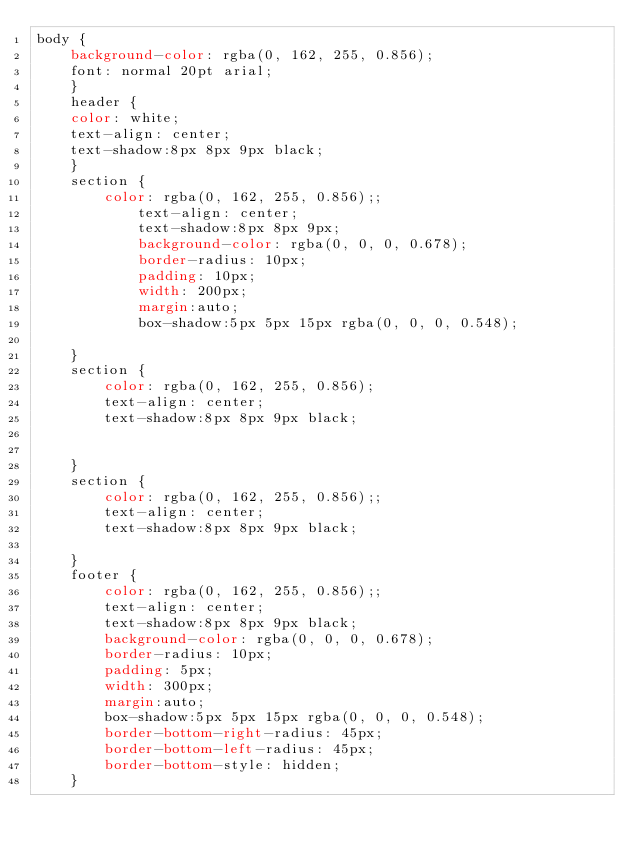Convert code to text. <code><loc_0><loc_0><loc_500><loc_500><_CSS_>body {
    background-color: rgba(0, 162, 255, 0.856);
    font: normal 20pt arial;
    }
    header {
    color: white;
    text-align: center;
    text-shadow:8px 8px 9px black;
    }
    section {
        color: rgba(0, 162, 255, 0.856);;
            text-align: center;   
            text-shadow:8px 8px 9px;
            background-color: rgba(0, 0, 0, 0.678);
            border-radius: 10px;
            padding: 10px;
            width: 200px;
            margin:auto;
            box-shadow:5px 5px 15px rgba(0, 0, 0, 0.548);
            
    }
    section {
        color: rgba(0, 162, 255, 0.856);
        text-align: center;
        text-shadow:8px 8px 9px black;
       
    
    }
    section {
        color: rgba(0, 162, 255, 0.856);;
        text-align: center;
        text-shadow:8px 8px 9px black;

    }
    footer {
        color: rgba(0, 162, 255, 0.856);;
        text-align: center;
        text-shadow:8px 8px 9px black;
        background-color: rgba(0, 0, 0, 0.678);
        border-radius: 10px;
        padding: 5px;
        width: 300px;
        margin:auto;
        box-shadow:5px 5px 15px rgba(0, 0, 0, 0.548);  
        border-bottom-right-radius: 45px;
        border-bottom-left-radius: 45px;
        border-bottom-style: hidden;
    }</code> 